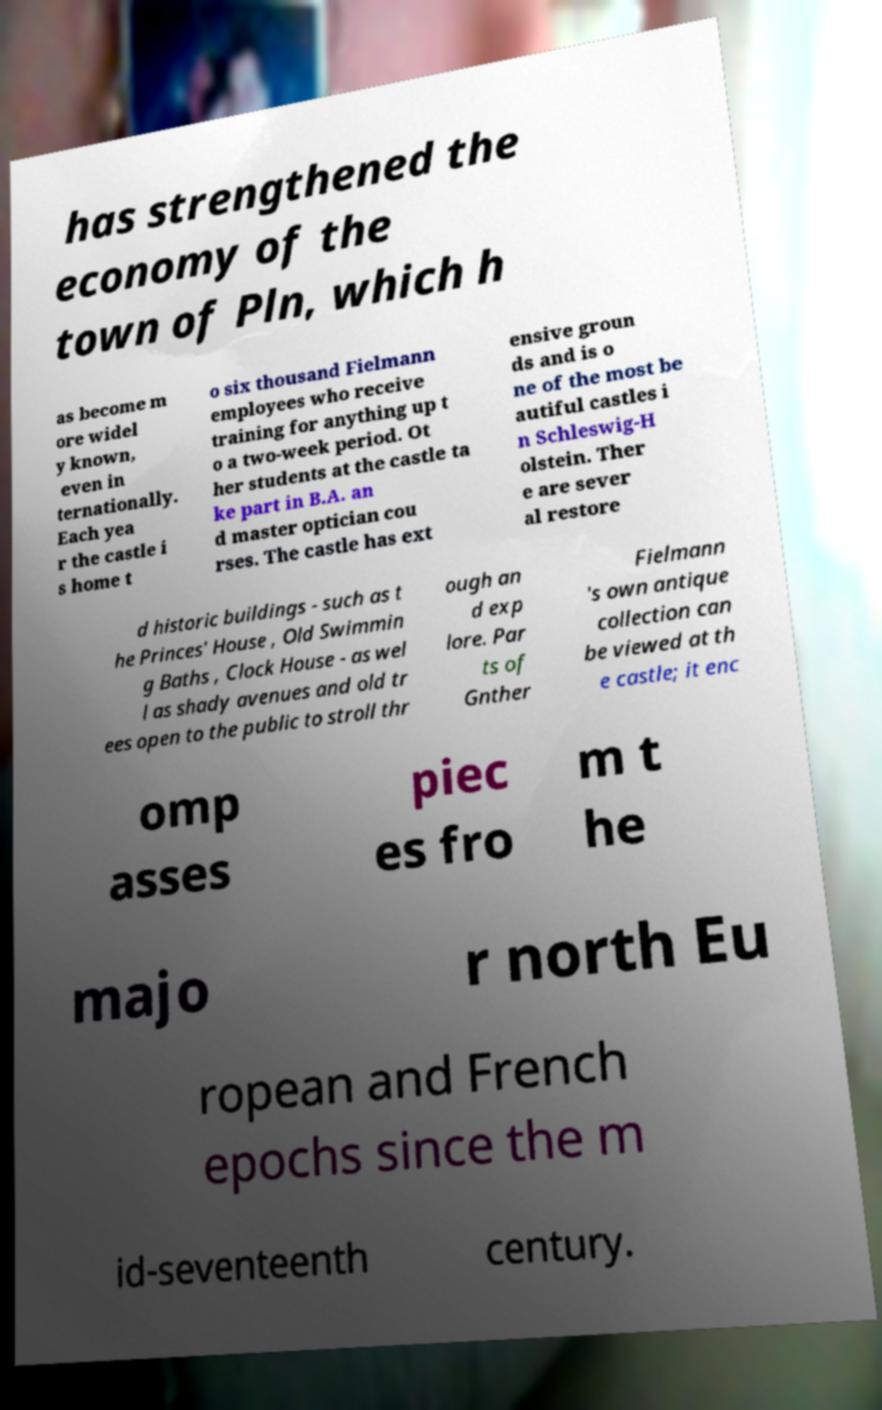Please identify and transcribe the text found in this image. has strengthened the economy of the town of Pln, which h as become m ore widel y known, even in ternationally. Each yea r the castle i s home t o six thousand Fielmann employees who receive training for anything up t o a two-week period. Ot her students at the castle ta ke part in B.A. an d master optician cou rses. The castle has ext ensive groun ds and is o ne of the most be autiful castles i n Schleswig-H olstein. Ther e are sever al restore d historic buildings - such as t he Princes' House , Old Swimmin g Baths , Clock House - as wel l as shady avenues and old tr ees open to the public to stroll thr ough an d exp lore. Par ts of Gnther Fielmann 's own antique collection can be viewed at th e castle; it enc omp asses piec es fro m t he majo r north Eu ropean and French epochs since the m id-seventeenth century. 